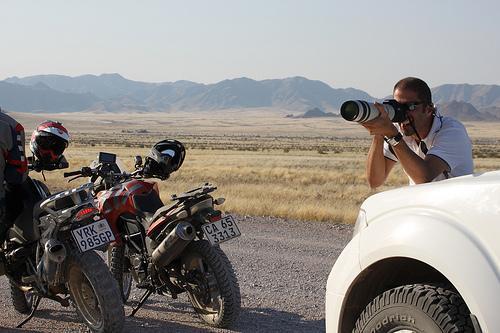How many motorcycles are in the picture?
Give a very brief answer. 2. 